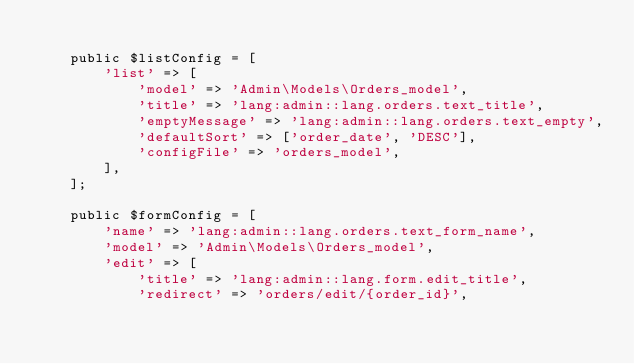<code> <loc_0><loc_0><loc_500><loc_500><_PHP_>
    public $listConfig = [
        'list' => [
            'model' => 'Admin\Models\Orders_model',
            'title' => 'lang:admin::lang.orders.text_title',
            'emptyMessage' => 'lang:admin::lang.orders.text_empty',
            'defaultSort' => ['order_date', 'DESC'],
            'configFile' => 'orders_model',
        ],
    ];

    public $formConfig = [
        'name' => 'lang:admin::lang.orders.text_form_name',
        'model' => 'Admin\Models\Orders_model',
        'edit' => [
            'title' => 'lang:admin::lang.form.edit_title',
            'redirect' => 'orders/edit/{order_id}',</code> 